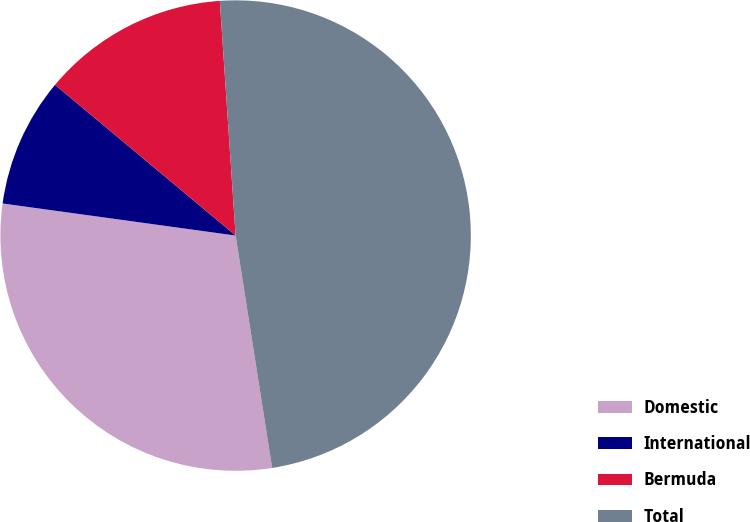<chart> <loc_0><loc_0><loc_500><loc_500><pie_chart><fcel>Domestic<fcel>International<fcel>Bermuda<fcel>Total<nl><fcel>29.66%<fcel>8.89%<fcel>12.86%<fcel>48.59%<nl></chart> 